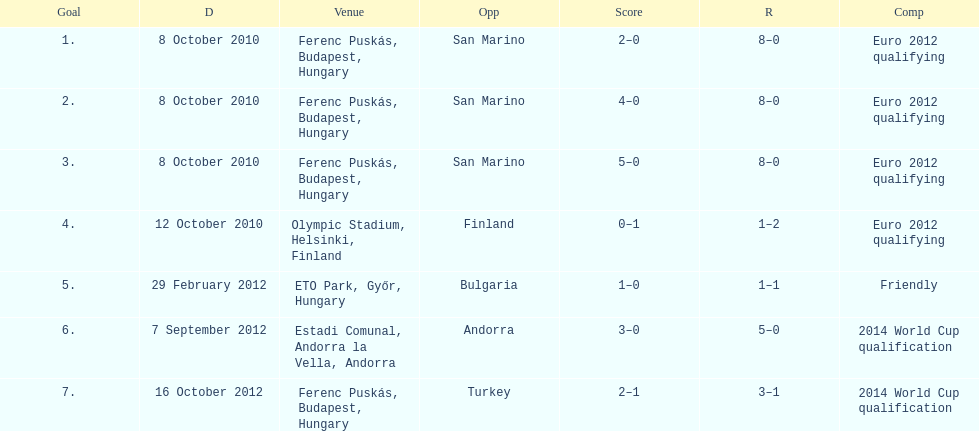Szalai scored only one more international goal against all other countries put together than he did against what one country? San Marino. 